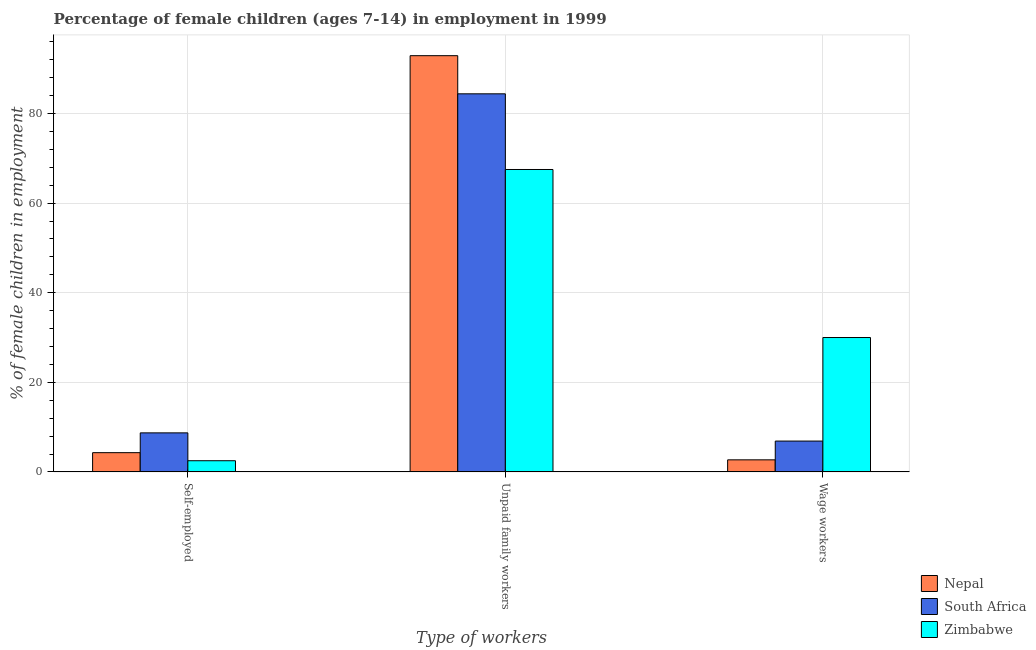How many different coloured bars are there?
Provide a succinct answer. 3. How many bars are there on the 1st tick from the right?
Ensure brevity in your answer.  3. What is the label of the 1st group of bars from the left?
Provide a succinct answer. Self-employed. What is the percentage of self employed children in South Africa?
Make the answer very short. 8.72. Across all countries, what is the maximum percentage of self employed children?
Provide a succinct answer. 8.72. In which country was the percentage of children employed as unpaid family workers maximum?
Provide a short and direct response. Nepal. In which country was the percentage of children employed as unpaid family workers minimum?
Provide a short and direct response. Zimbabwe. What is the total percentage of children employed as wage workers in the graph?
Offer a very short reply. 39.59. What is the difference between the percentage of children employed as unpaid family workers in Nepal and that in Zimbabwe?
Offer a terse response. 25.4. What is the difference between the percentage of children employed as wage workers in South Africa and the percentage of children employed as unpaid family workers in Nepal?
Give a very brief answer. -86.01. What is the average percentage of children employed as wage workers per country?
Your response must be concise. 13.2. What is the difference between the percentage of children employed as wage workers and percentage of children employed as unpaid family workers in South Africa?
Offer a terse response. -77.5. In how many countries, is the percentage of self employed children greater than 24 %?
Make the answer very short. 0. What is the ratio of the percentage of children employed as wage workers in Zimbabwe to that in Nepal?
Provide a succinct answer. 11.11. Is the percentage of children employed as unpaid family workers in Nepal less than that in Zimbabwe?
Offer a very short reply. No. Is the difference between the percentage of children employed as unpaid family workers in South Africa and Zimbabwe greater than the difference between the percentage of self employed children in South Africa and Zimbabwe?
Provide a short and direct response. Yes. What is the difference between the highest and the second highest percentage of self employed children?
Offer a very short reply. 4.42. What is the difference between the highest and the lowest percentage of children employed as unpaid family workers?
Provide a succinct answer. 25.4. In how many countries, is the percentage of children employed as unpaid family workers greater than the average percentage of children employed as unpaid family workers taken over all countries?
Keep it short and to the point. 2. Is the sum of the percentage of children employed as wage workers in Nepal and Zimbabwe greater than the maximum percentage of children employed as unpaid family workers across all countries?
Your answer should be compact. No. What does the 2nd bar from the left in Self-employed represents?
Offer a terse response. South Africa. What does the 3rd bar from the right in Self-employed represents?
Provide a succinct answer. Nepal. Is it the case that in every country, the sum of the percentage of self employed children and percentage of children employed as unpaid family workers is greater than the percentage of children employed as wage workers?
Make the answer very short. Yes. How many bars are there?
Ensure brevity in your answer.  9. Are all the bars in the graph horizontal?
Ensure brevity in your answer.  No. What is the difference between two consecutive major ticks on the Y-axis?
Your answer should be very brief. 20. Does the graph contain any zero values?
Offer a terse response. No. How many legend labels are there?
Your response must be concise. 3. How are the legend labels stacked?
Provide a succinct answer. Vertical. What is the title of the graph?
Keep it short and to the point. Percentage of female children (ages 7-14) in employment in 1999. Does "Czech Republic" appear as one of the legend labels in the graph?
Keep it short and to the point. No. What is the label or title of the X-axis?
Provide a succinct answer. Type of workers. What is the label or title of the Y-axis?
Make the answer very short. % of female children in employment. What is the % of female children in employment in Nepal in Self-employed?
Provide a short and direct response. 4.3. What is the % of female children in employment of South Africa in Self-employed?
Make the answer very short. 8.72. What is the % of female children in employment in Nepal in Unpaid family workers?
Give a very brief answer. 92.9. What is the % of female children in employment in South Africa in Unpaid family workers?
Your response must be concise. 84.39. What is the % of female children in employment of Zimbabwe in Unpaid family workers?
Provide a short and direct response. 67.5. What is the % of female children in employment of Nepal in Wage workers?
Ensure brevity in your answer.  2.7. What is the % of female children in employment of South Africa in Wage workers?
Make the answer very short. 6.89. What is the % of female children in employment in Zimbabwe in Wage workers?
Your response must be concise. 30. Across all Type of workers, what is the maximum % of female children in employment in Nepal?
Ensure brevity in your answer.  92.9. Across all Type of workers, what is the maximum % of female children in employment of South Africa?
Keep it short and to the point. 84.39. Across all Type of workers, what is the maximum % of female children in employment of Zimbabwe?
Make the answer very short. 67.5. Across all Type of workers, what is the minimum % of female children in employment of Nepal?
Your answer should be very brief. 2.7. Across all Type of workers, what is the minimum % of female children in employment of South Africa?
Keep it short and to the point. 6.89. What is the total % of female children in employment in Nepal in the graph?
Offer a terse response. 99.9. What is the total % of female children in employment of South Africa in the graph?
Your response must be concise. 100. What is the difference between the % of female children in employment of Nepal in Self-employed and that in Unpaid family workers?
Make the answer very short. -88.6. What is the difference between the % of female children in employment of South Africa in Self-employed and that in Unpaid family workers?
Offer a very short reply. -75.67. What is the difference between the % of female children in employment in Zimbabwe in Self-employed and that in Unpaid family workers?
Provide a succinct answer. -65. What is the difference between the % of female children in employment in Nepal in Self-employed and that in Wage workers?
Your answer should be very brief. 1.6. What is the difference between the % of female children in employment of South Africa in Self-employed and that in Wage workers?
Provide a succinct answer. 1.83. What is the difference between the % of female children in employment in Zimbabwe in Self-employed and that in Wage workers?
Your response must be concise. -27.5. What is the difference between the % of female children in employment in Nepal in Unpaid family workers and that in Wage workers?
Make the answer very short. 90.2. What is the difference between the % of female children in employment of South Africa in Unpaid family workers and that in Wage workers?
Your answer should be very brief. 77.5. What is the difference between the % of female children in employment of Zimbabwe in Unpaid family workers and that in Wage workers?
Offer a terse response. 37.5. What is the difference between the % of female children in employment of Nepal in Self-employed and the % of female children in employment of South Africa in Unpaid family workers?
Offer a very short reply. -80.09. What is the difference between the % of female children in employment of Nepal in Self-employed and the % of female children in employment of Zimbabwe in Unpaid family workers?
Your response must be concise. -63.2. What is the difference between the % of female children in employment in South Africa in Self-employed and the % of female children in employment in Zimbabwe in Unpaid family workers?
Your answer should be very brief. -58.78. What is the difference between the % of female children in employment in Nepal in Self-employed and the % of female children in employment in South Africa in Wage workers?
Keep it short and to the point. -2.59. What is the difference between the % of female children in employment in Nepal in Self-employed and the % of female children in employment in Zimbabwe in Wage workers?
Keep it short and to the point. -25.7. What is the difference between the % of female children in employment of South Africa in Self-employed and the % of female children in employment of Zimbabwe in Wage workers?
Your answer should be very brief. -21.28. What is the difference between the % of female children in employment of Nepal in Unpaid family workers and the % of female children in employment of South Africa in Wage workers?
Make the answer very short. 86.01. What is the difference between the % of female children in employment in Nepal in Unpaid family workers and the % of female children in employment in Zimbabwe in Wage workers?
Offer a terse response. 62.9. What is the difference between the % of female children in employment in South Africa in Unpaid family workers and the % of female children in employment in Zimbabwe in Wage workers?
Your response must be concise. 54.39. What is the average % of female children in employment of Nepal per Type of workers?
Make the answer very short. 33.3. What is the average % of female children in employment of South Africa per Type of workers?
Keep it short and to the point. 33.33. What is the average % of female children in employment of Zimbabwe per Type of workers?
Offer a terse response. 33.33. What is the difference between the % of female children in employment of Nepal and % of female children in employment of South Africa in Self-employed?
Keep it short and to the point. -4.42. What is the difference between the % of female children in employment in Nepal and % of female children in employment in Zimbabwe in Self-employed?
Your answer should be very brief. 1.8. What is the difference between the % of female children in employment of South Africa and % of female children in employment of Zimbabwe in Self-employed?
Provide a short and direct response. 6.22. What is the difference between the % of female children in employment of Nepal and % of female children in employment of South Africa in Unpaid family workers?
Your answer should be very brief. 8.51. What is the difference between the % of female children in employment of Nepal and % of female children in employment of Zimbabwe in Unpaid family workers?
Your answer should be very brief. 25.4. What is the difference between the % of female children in employment of South Africa and % of female children in employment of Zimbabwe in Unpaid family workers?
Provide a short and direct response. 16.89. What is the difference between the % of female children in employment in Nepal and % of female children in employment in South Africa in Wage workers?
Ensure brevity in your answer.  -4.19. What is the difference between the % of female children in employment of Nepal and % of female children in employment of Zimbabwe in Wage workers?
Your response must be concise. -27.3. What is the difference between the % of female children in employment in South Africa and % of female children in employment in Zimbabwe in Wage workers?
Offer a very short reply. -23.11. What is the ratio of the % of female children in employment of Nepal in Self-employed to that in Unpaid family workers?
Offer a terse response. 0.05. What is the ratio of the % of female children in employment of South Africa in Self-employed to that in Unpaid family workers?
Make the answer very short. 0.1. What is the ratio of the % of female children in employment in Zimbabwe in Self-employed to that in Unpaid family workers?
Keep it short and to the point. 0.04. What is the ratio of the % of female children in employment in Nepal in Self-employed to that in Wage workers?
Provide a succinct answer. 1.59. What is the ratio of the % of female children in employment of South Africa in Self-employed to that in Wage workers?
Offer a very short reply. 1.27. What is the ratio of the % of female children in employment in Zimbabwe in Self-employed to that in Wage workers?
Offer a very short reply. 0.08. What is the ratio of the % of female children in employment of Nepal in Unpaid family workers to that in Wage workers?
Ensure brevity in your answer.  34.41. What is the ratio of the % of female children in employment in South Africa in Unpaid family workers to that in Wage workers?
Offer a very short reply. 12.25. What is the ratio of the % of female children in employment of Zimbabwe in Unpaid family workers to that in Wage workers?
Give a very brief answer. 2.25. What is the difference between the highest and the second highest % of female children in employment in Nepal?
Your answer should be very brief. 88.6. What is the difference between the highest and the second highest % of female children in employment of South Africa?
Keep it short and to the point. 75.67. What is the difference between the highest and the second highest % of female children in employment of Zimbabwe?
Make the answer very short. 37.5. What is the difference between the highest and the lowest % of female children in employment in Nepal?
Your answer should be compact. 90.2. What is the difference between the highest and the lowest % of female children in employment in South Africa?
Give a very brief answer. 77.5. 